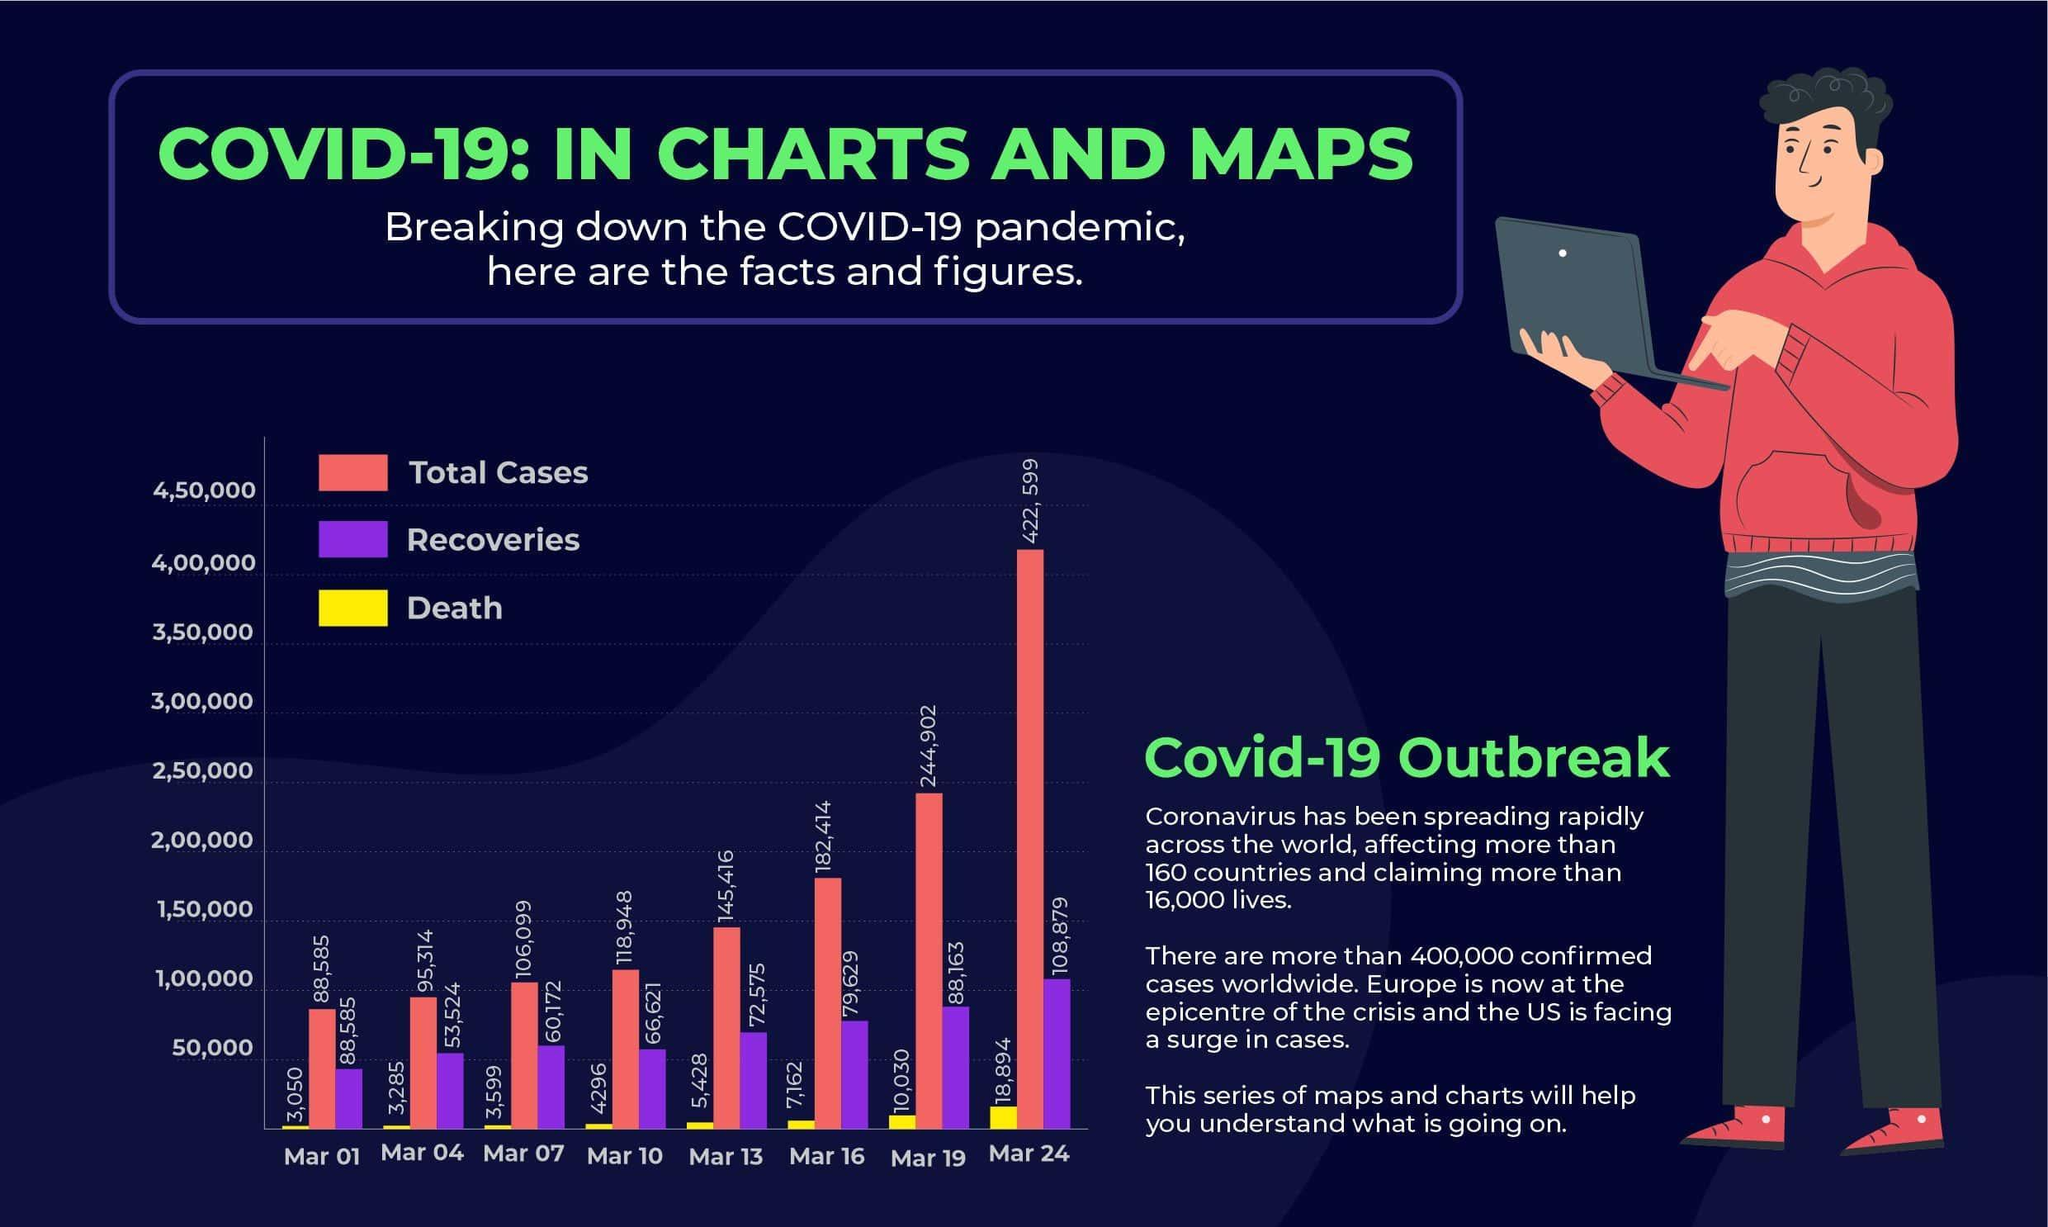On which day did the total cases cross 4,00,000?
Answer the question with a short phrase. Mar 24 On which day did total cases reach the highest? Mar 24 Which parameter is represented using purple colour? Recoveries Which days had total cases below 1,00,000? Mar 01, Mar 04 How many people have recovered up till March 19? 88,163 By what number did the total cases increase from Mar 10 to Mar 19? 125,954 What was the total number of cases on March 16? 182,414 How many deaths took place during March 10? 4296 By what colour has been death represented on the graph- yellow, red or purple? yellow 